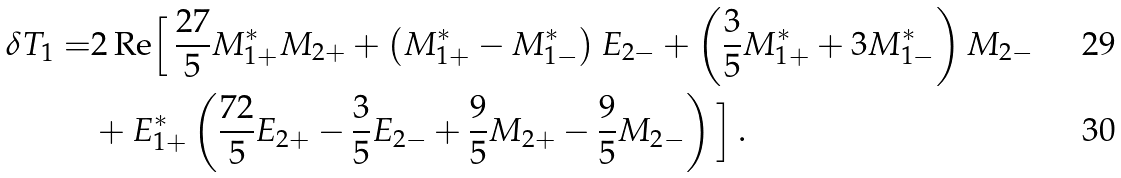Convert formula to latex. <formula><loc_0><loc_0><loc_500><loc_500>\delta T _ { 1 } = & 2 \, \text {Re} \Big { [ } \, \frac { 2 7 } { 5 } M ^ { * } _ { 1 + } M _ { 2 + } + \left ( M ^ { * } _ { 1 + } - M ^ { * } _ { 1 - } \right ) E _ { 2 - } + \left ( \frac { 3 } { 5 } M ^ { * } _ { 1 + } + 3 M ^ { * } _ { 1 - } \right ) M _ { 2 - } \\ & + E ^ { * } _ { 1 + } \left ( \frac { 7 2 } { 5 } E _ { 2 + } - \frac { 3 } { 5 } E _ { 2 - } + \frac { 9 } { 5 } M _ { 2 + } - \frac { 9 } { 5 } M _ { 2 - } \right ) \Big { ] } \, .</formula> 